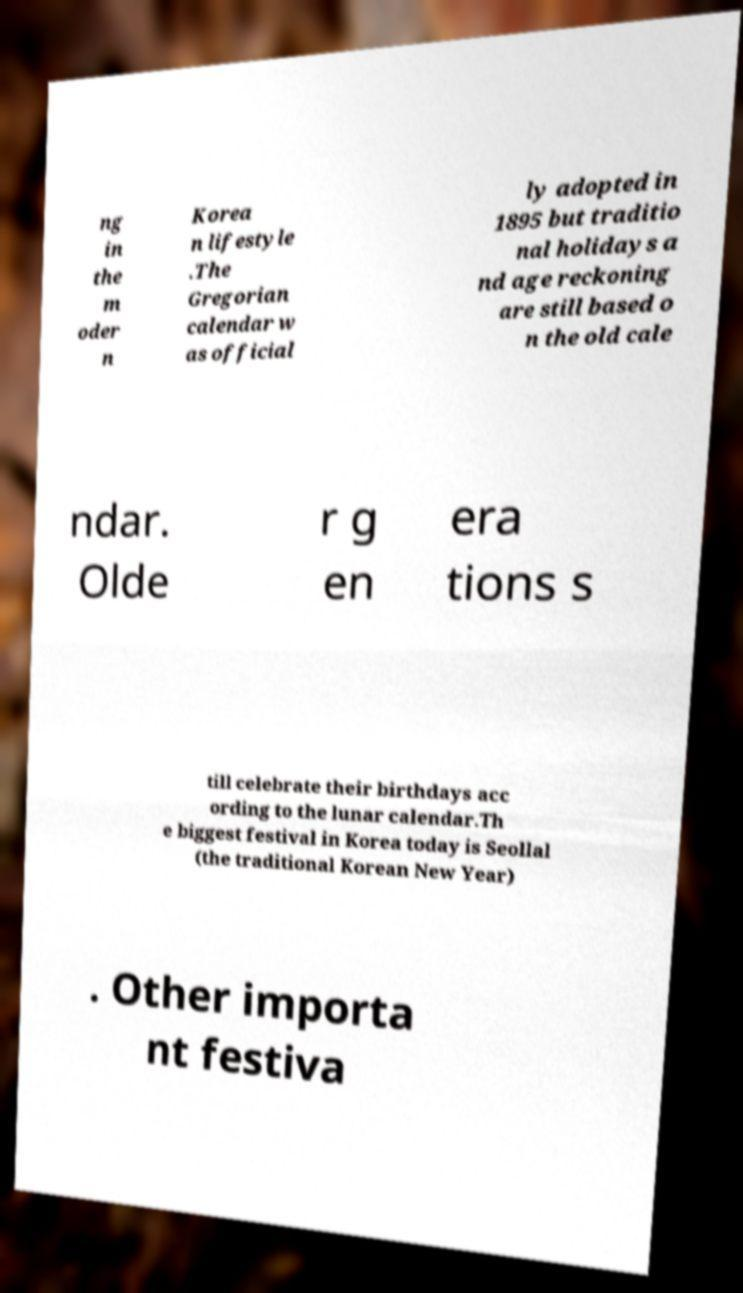Please identify and transcribe the text found in this image. ng in the m oder n Korea n lifestyle .The Gregorian calendar w as official ly adopted in 1895 but traditio nal holidays a nd age reckoning are still based o n the old cale ndar. Olde r g en era tions s till celebrate their birthdays acc ording to the lunar calendar.Th e biggest festival in Korea today is Seollal (the traditional Korean New Year) . Other importa nt festiva 